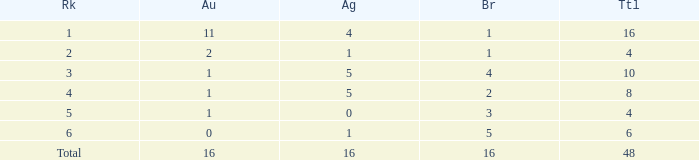How many gold are a rank 1 and larger than 16? 0.0. 